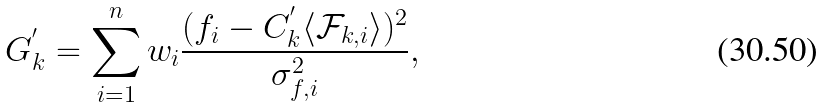<formula> <loc_0><loc_0><loc_500><loc_500>G _ { k } ^ { ^ { \prime } } = \sum _ { i = 1 } ^ { n } w _ { i } { \frac { ( f _ { i } - C _ { k } ^ { ^ { \prime } } \langle \mathcal { F } _ { k , i } \rangle ) ^ { 2 } } { \sigma _ { f , i } ^ { 2 } } } ,</formula> 